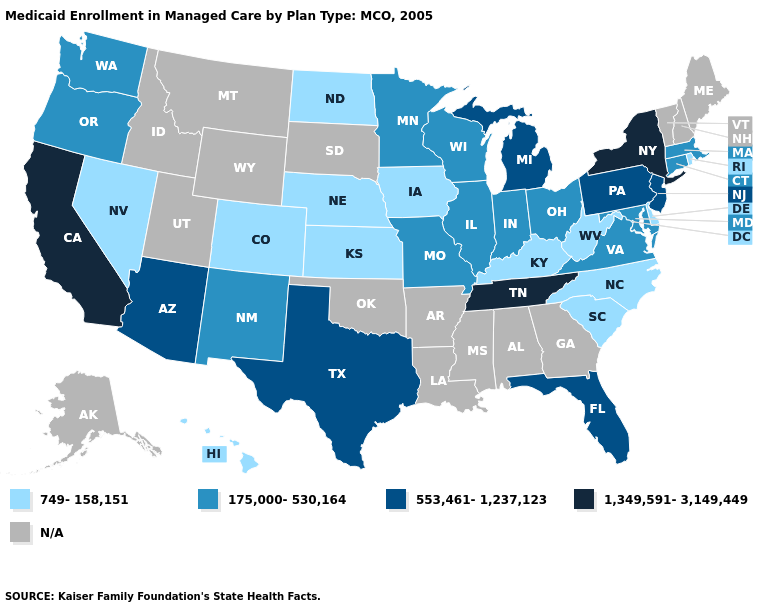Does Iowa have the lowest value in the USA?
Be succinct. Yes. Name the states that have a value in the range 749-158,151?
Answer briefly. Colorado, Delaware, Hawaii, Iowa, Kansas, Kentucky, Nebraska, Nevada, North Carolina, North Dakota, Rhode Island, South Carolina, West Virginia. Name the states that have a value in the range 175,000-530,164?
Write a very short answer. Connecticut, Illinois, Indiana, Maryland, Massachusetts, Minnesota, Missouri, New Mexico, Ohio, Oregon, Virginia, Washington, Wisconsin. Is the legend a continuous bar?
Be succinct. No. What is the value of Mississippi?
Write a very short answer. N/A. What is the value of New York?
Give a very brief answer. 1,349,591-3,149,449. What is the lowest value in the USA?
Quick response, please. 749-158,151. Which states have the lowest value in the USA?
Short answer required. Colorado, Delaware, Hawaii, Iowa, Kansas, Kentucky, Nebraska, Nevada, North Carolina, North Dakota, Rhode Island, South Carolina, West Virginia. What is the lowest value in the USA?
Quick response, please. 749-158,151. What is the value of Washington?
Keep it brief. 175,000-530,164. Which states have the highest value in the USA?
Answer briefly. California, New York, Tennessee. Is the legend a continuous bar?
Concise answer only. No. What is the value of West Virginia?
Be succinct. 749-158,151. Name the states that have a value in the range 553,461-1,237,123?
Short answer required. Arizona, Florida, Michigan, New Jersey, Pennsylvania, Texas. 